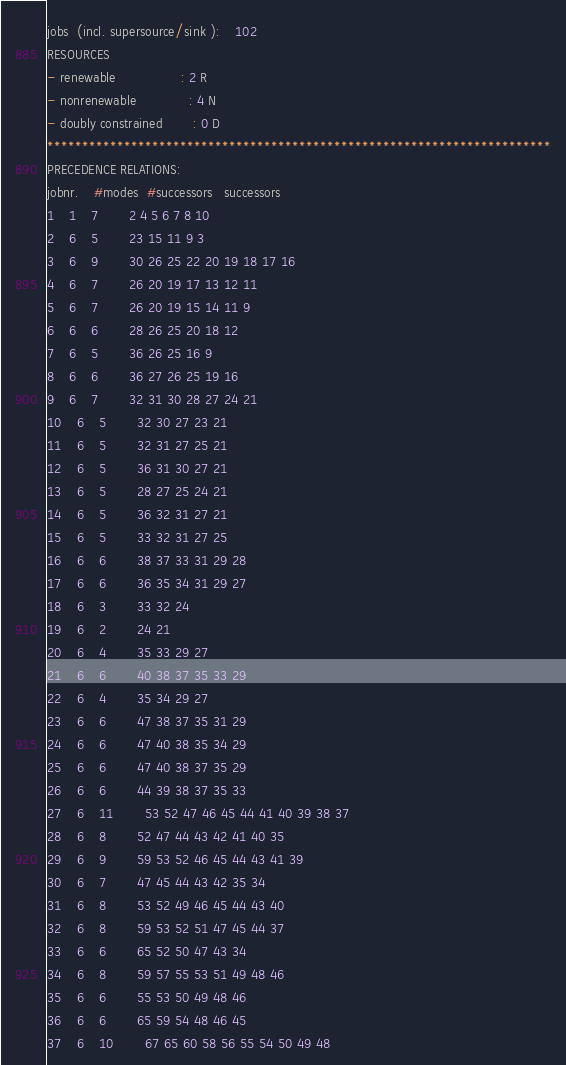Convert code to text. <code><loc_0><loc_0><loc_500><loc_500><_ObjectiveC_>jobs  (incl. supersource/sink ):	102
RESOURCES
- renewable                 : 2 R
- nonrenewable              : 4 N
- doubly constrained        : 0 D
************************************************************************
PRECEDENCE RELATIONS:
jobnr.    #modes  #successors   successors
1	1	7		2 4 5 6 7 8 10 
2	6	5		23 15 11 9 3 
3	6	9		30 26 25 22 20 19 18 17 16 
4	6	7		26 20 19 17 13 12 11 
5	6	7		26 20 19 15 14 11 9 
6	6	6		28 26 25 20 18 12 
7	6	5		36 26 25 16 9 
8	6	6		36 27 26 25 19 16 
9	6	7		32 31 30 28 27 24 21 
10	6	5		32 30 27 23 21 
11	6	5		32 31 27 25 21 
12	6	5		36 31 30 27 21 
13	6	5		28 27 25 24 21 
14	6	5		36 32 31 27 21 
15	6	5		33 32 31 27 25 
16	6	6		38 37 33 31 29 28 
17	6	6		36 35 34 31 29 27 
18	6	3		33 32 24 
19	6	2		24 21 
20	6	4		35 33 29 27 
21	6	6		40 38 37 35 33 29 
22	6	4		35 34 29 27 
23	6	6		47 38 37 35 31 29 
24	6	6		47 40 38 35 34 29 
25	6	6		47 40 38 37 35 29 
26	6	6		44 39 38 37 35 33 
27	6	11		53 52 47 46 45 44 41 40 39 38 37 
28	6	8		52 47 44 43 42 41 40 35 
29	6	9		59 53 52 46 45 44 43 41 39 
30	6	7		47 45 44 43 42 35 34 
31	6	8		53 52 49 46 45 44 43 40 
32	6	8		59 53 52 51 47 45 44 37 
33	6	6		65 52 50 47 43 34 
34	6	8		59 57 55 53 51 49 48 46 
35	6	6		55 53 50 49 48 46 
36	6	6		65 59 54 48 46 45 
37	6	10		67 65 60 58 56 55 54 50 49 48 </code> 